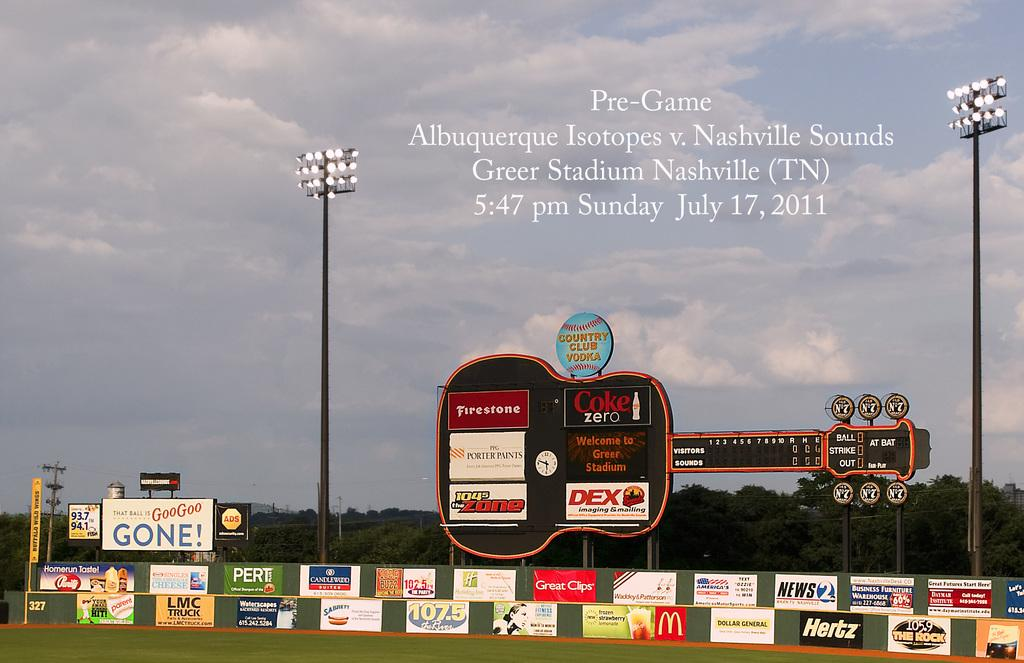<image>
Relay a brief, clear account of the picture shown. A picture of a field is used to advertise the time of a Pre-Game gathering. 